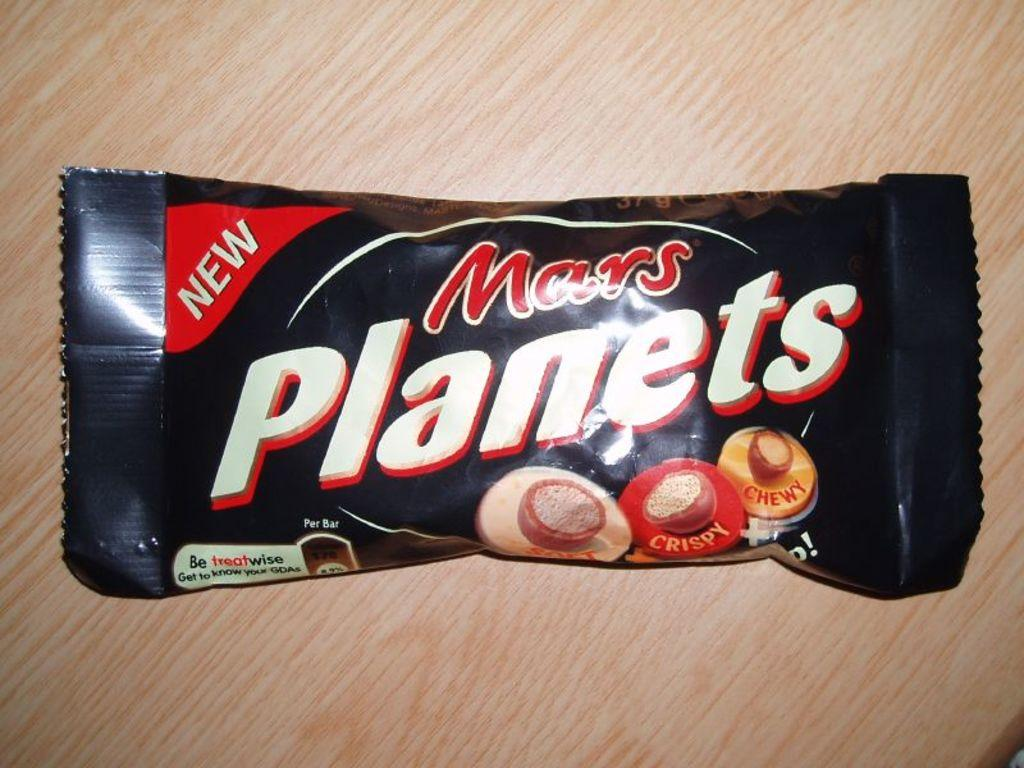What is the main subject of the image? The main subject of the image is a chocolate. Where is the chocolate located? The chocolate is on a table. Can you see a receipt for the chocolate in the image? There is no receipt present in the image; it only shows a chocolate on a table. How many lizards are crawling on the chocolate in the image? There are no lizards present in the image; it only shows a chocolate on a table. 